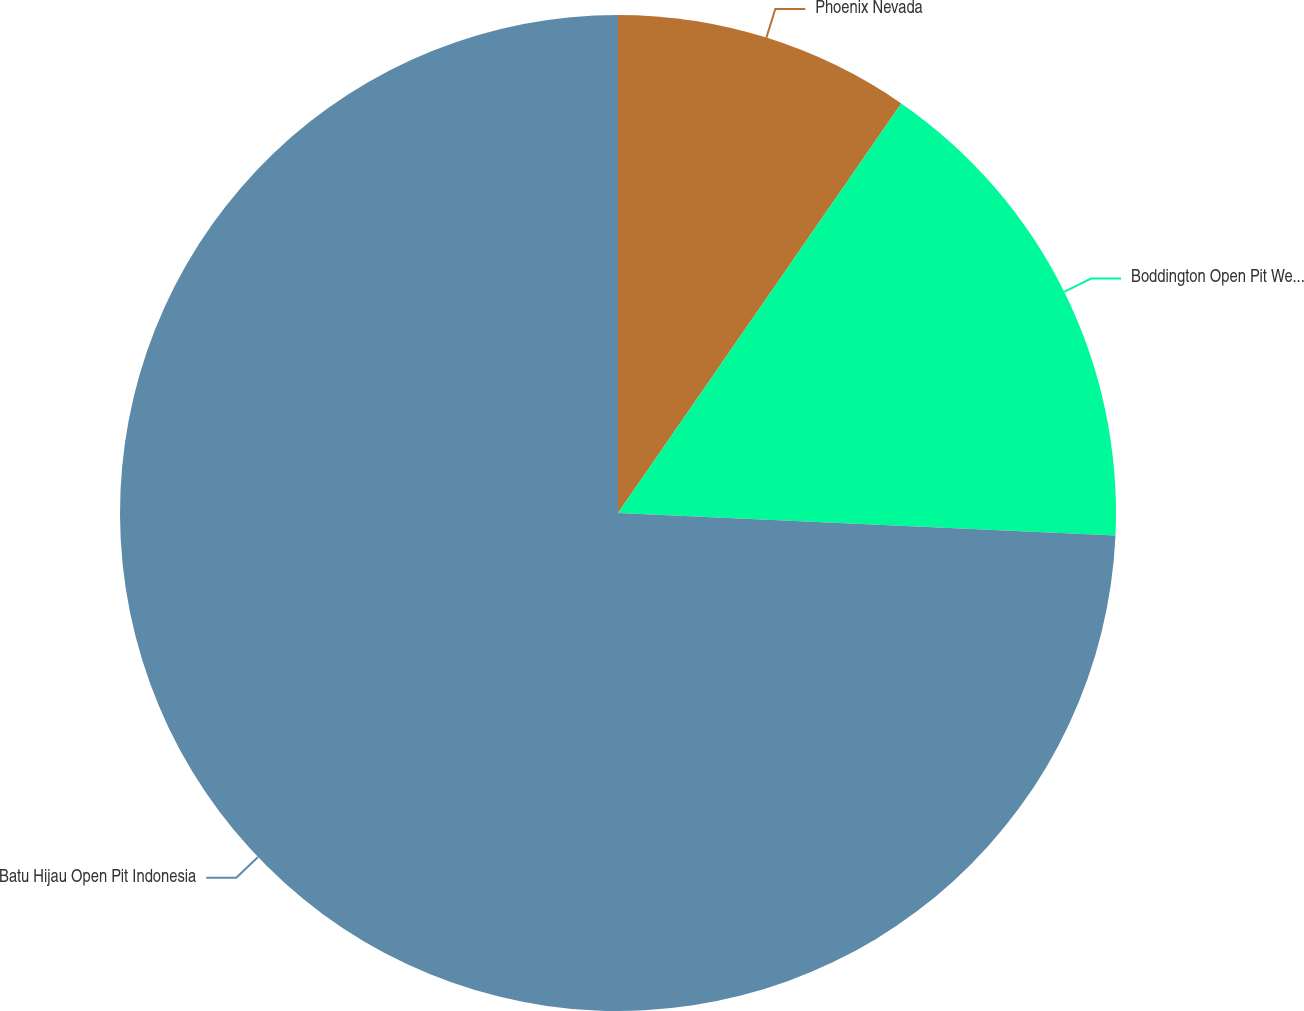Convert chart. <chart><loc_0><loc_0><loc_500><loc_500><pie_chart><fcel>Phoenix Nevada<fcel>Boddington Open Pit Western<fcel>Batu Hijau Open Pit Indonesia<nl><fcel>9.63%<fcel>16.09%<fcel>74.28%<nl></chart> 